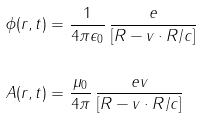<formula> <loc_0><loc_0><loc_500><loc_500>\phi ( r , t ) & = \frac { 1 } { 4 \pi \epsilon _ { 0 } } \, \frac { e } { [ R - v \cdot R / c ] } \\ \\ A ( r , t ) & = \frac { \mu _ { 0 } } { 4 \pi } \, \frac { e v } { [ R - v \cdot R / c ] }</formula> 